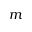Convert formula to latex. <formula><loc_0><loc_0><loc_500><loc_500>m</formula> 